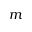Convert formula to latex. <formula><loc_0><loc_0><loc_500><loc_500>m</formula> 